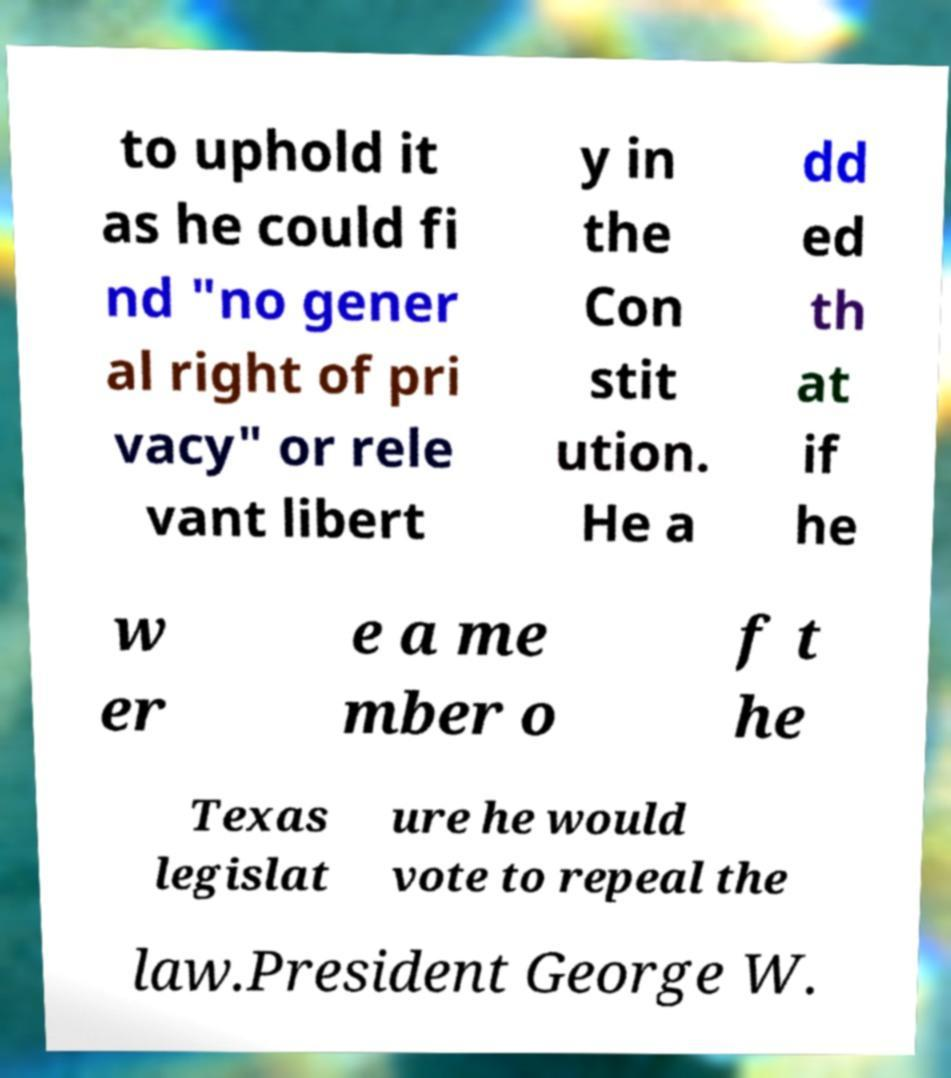I need the written content from this picture converted into text. Can you do that? to uphold it as he could fi nd "no gener al right of pri vacy" or rele vant libert y in the Con stit ution. He a dd ed th at if he w er e a me mber o f t he Texas legislat ure he would vote to repeal the law.President George W. 